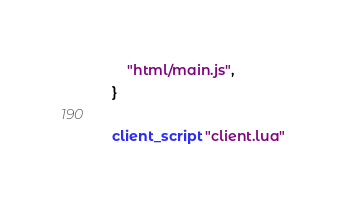<code> <loc_0><loc_0><loc_500><loc_500><_Lua_>	"html/main.js",
}

client_script "client.lua"</code> 